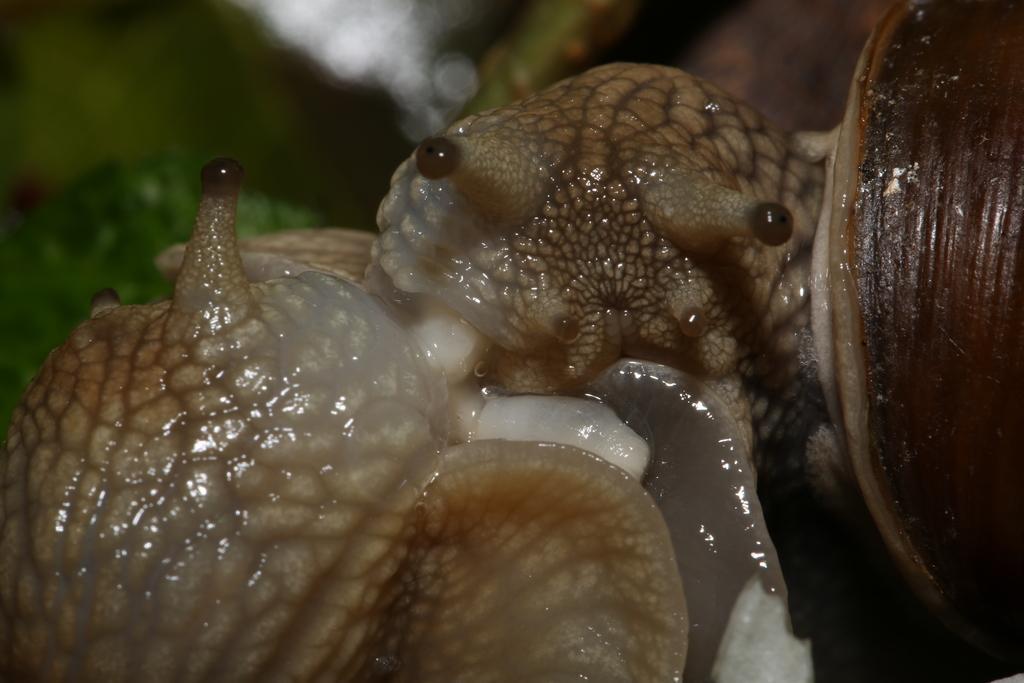Can you describe this image briefly? In this image we can see the snails and the background is blurred. 